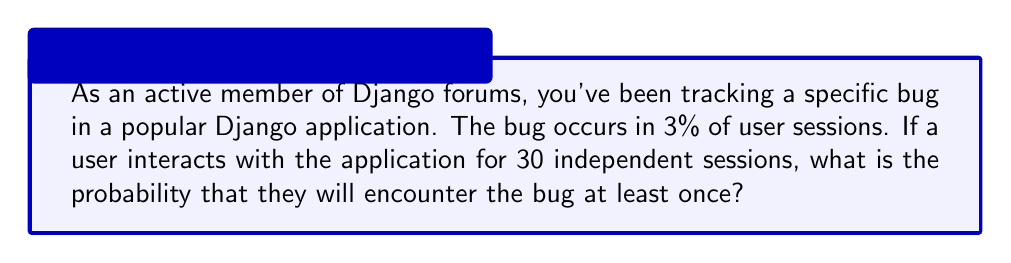What is the answer to this math problem? To solve this problem, we'll use the complement rule of probability. Instead of calculating the probability of encountering the bug at least once, we'll calculate the probability of not encountering the bug in any of the 30 sessions and then subtract that from 1.

Let's break it down step-by-step:

1. Probability of encountering the bug in a single session: $p = 0.03$ (3%)
2. Probability of not encountering the bug in a single session: $1 - p = 1 - 0.03 = 0.97$ (97%)
3. Number of independent sessions: $n = 30$

The probability of not encountering the bug in all 30 sessions is:

$$(0.97)^{30}$$

Now, to find the probability of encountering the bug at least once, we subtract this value from 1:

$$1 - (0.97)^{30}$$

Let's calculate this:

$$\begin{align*}
1 - (0.97)^{30} &= 1 - 0.4012796...\\
&\approx 0.5987203...
\end{align*}$$

Converting to a percentage:

$$0.5987203... \times 100\% \approx 59.87\%$$
Answer: The probability that a user will encounter the bug at least once in 30 independent sessions is approximately 59.87%. 